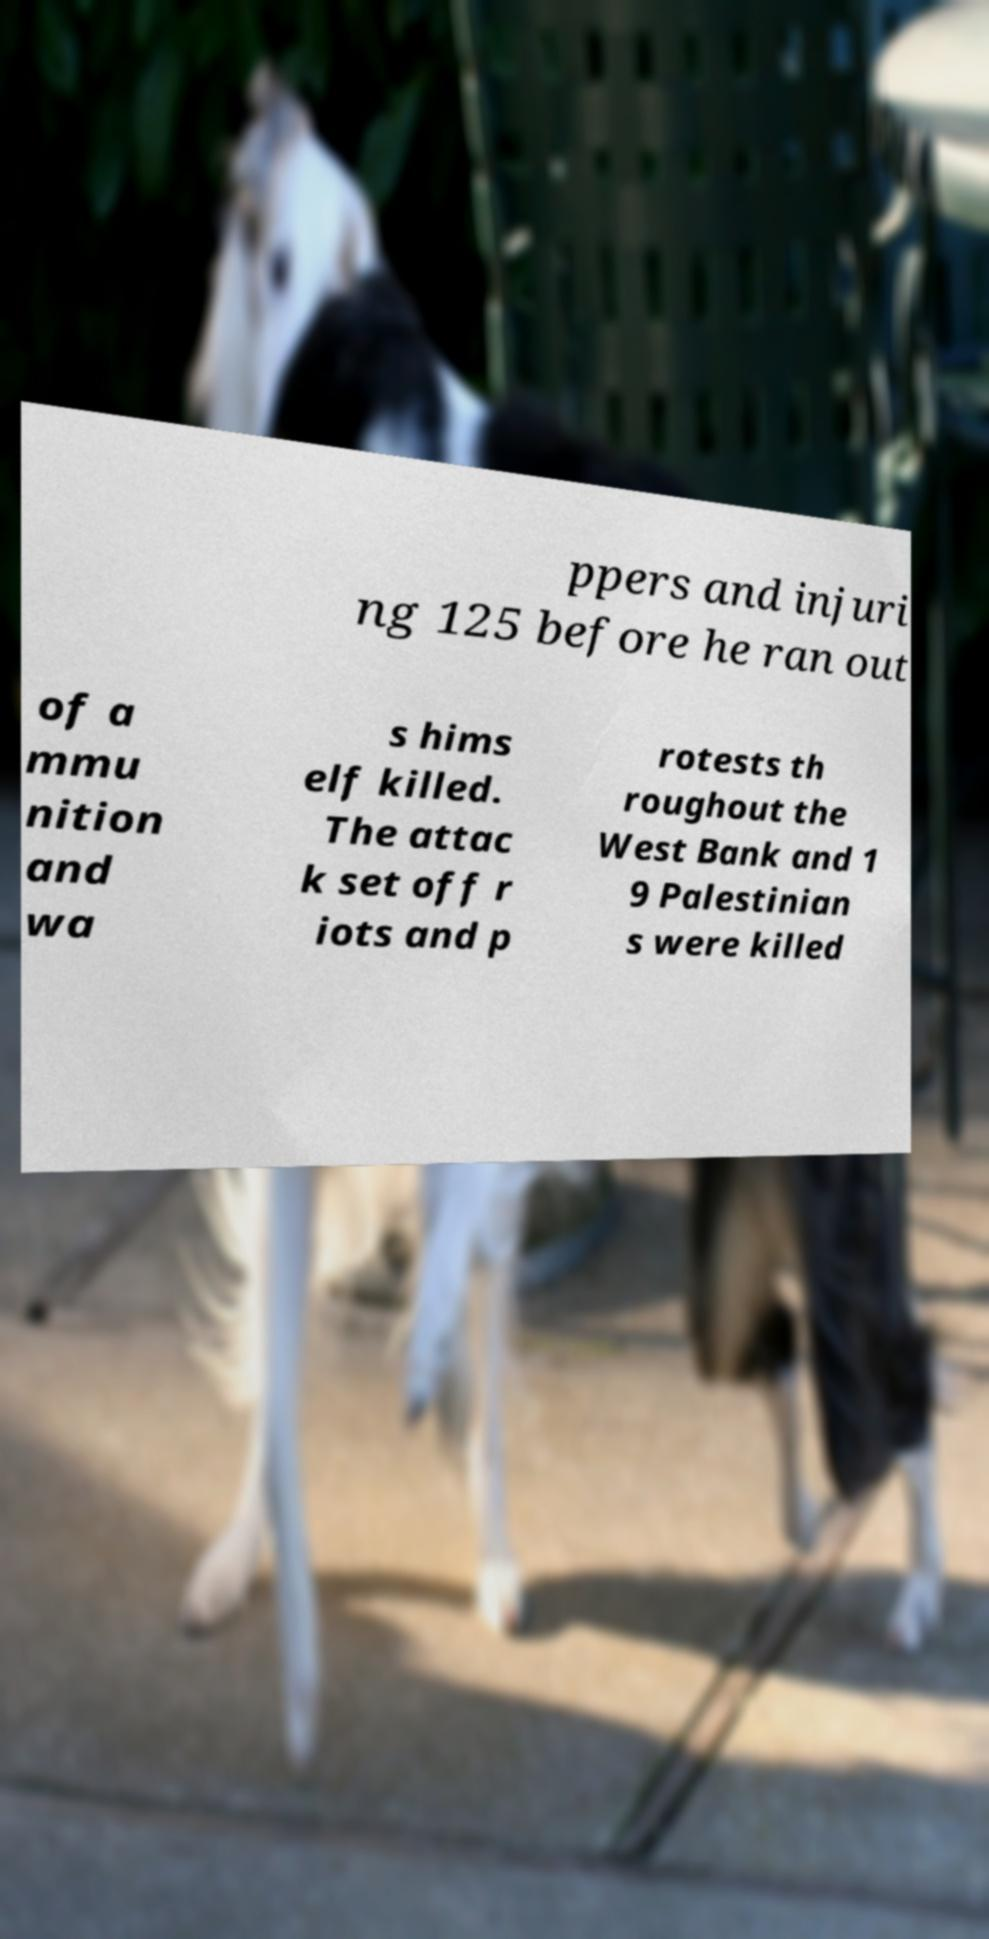Can you accurately transcribe the text from the provided image for me? ppers and injuri ng 125 before he ran out of a mmu nition and wa s hims elf killed. The attac k set off r iots and p rotests th roughout the West Bank and 1 9 Palestinian s were killed 